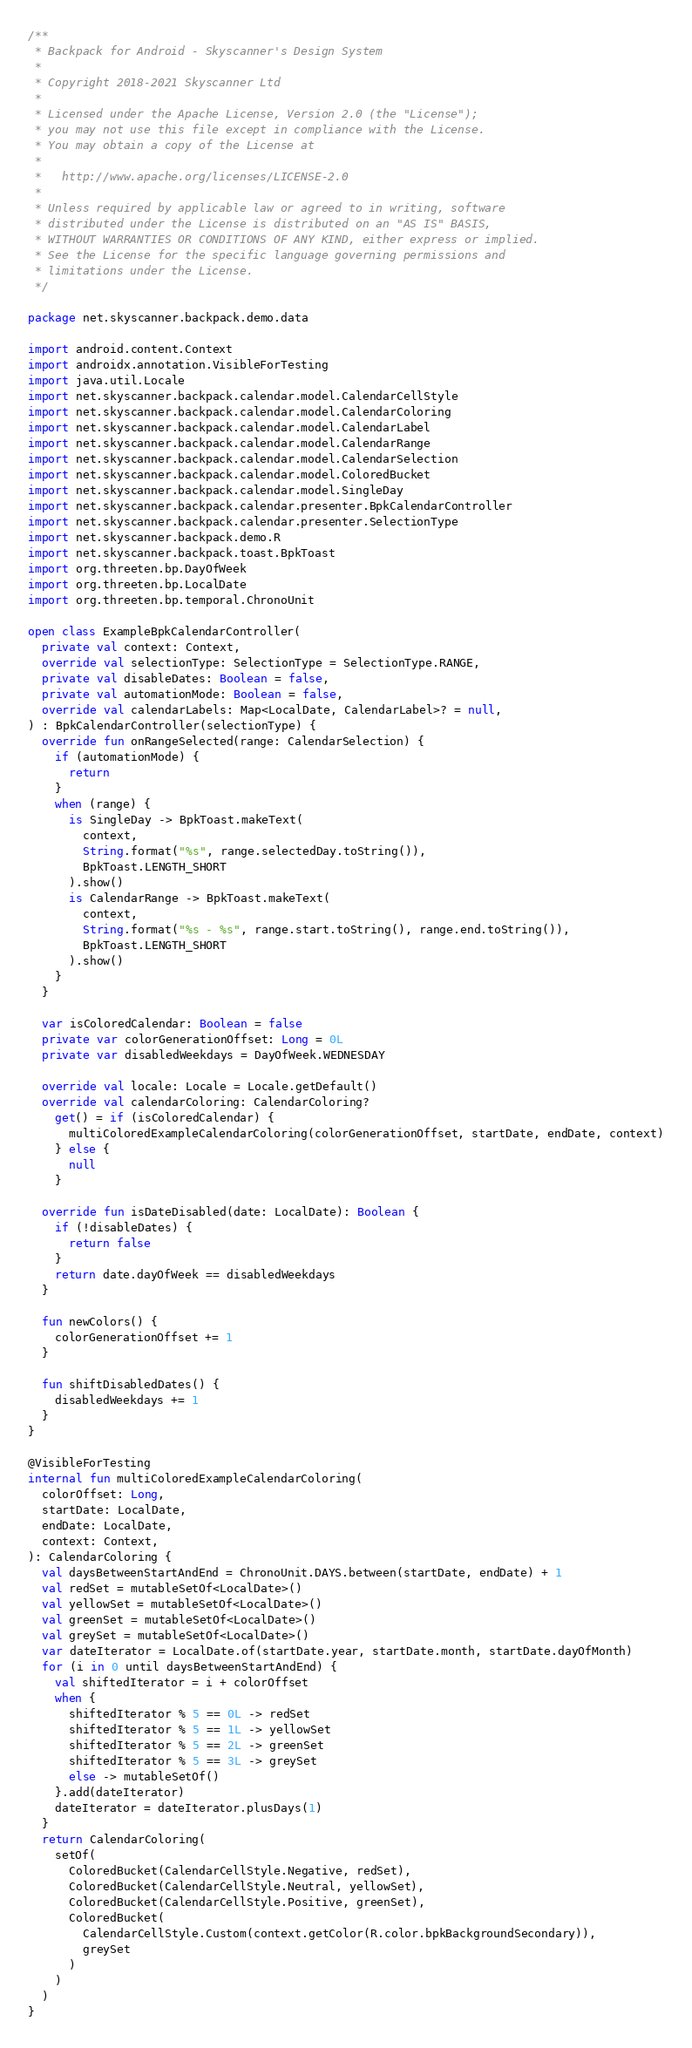<code> <loc_0><loc_0><loc_500><loc_500><_Kotlin_>/**
 * Backpack for Android - Skyscanner's Design System
 *
 * Copyright 2018-2021 Skyscanner Ltd
 *
 * Licensed under the Apache License, Version 2.0 (the "License");
 * you may not use this file except in compliance with the License.
 * You may obtain a copy of the License at
 *
 *   http://www.apache.org/licenses/LICENSE-2.0
 *
 * Unless required by applicable law or agreed to in writing, software
 * distributed under the License is distributed on an "AS IS" BASIS,
 * WITHOUT WARRANTIES OR CONDITIONS OF ANY KIND, either express or implied.
 * See the License for the specific language governing permissions and
 * limitations under the License.
 */

package net.skyscanner.backpack.demo.data

import android.content.Context
import androidx.annotation.VisibleForTesting
import java.util.Locale
import net.skyscanner.backpack.calendar.model.CalendarCellStyle
import net.skyscanner.backpack.calendar.model.CalendarColoring
import net.skyscanner.backpack.calendar.model.CalendarLabel
import net.skyscanner.backpack.calendar.model.CalendarRange
import net.skyscanner.backpack.calendar.model.CalendarSelection
import net.skyscanner.backpack.calendar.model.ColoredBucket
import net.skyscanner.backpack.calendar.model.SingleDay
import net.skyscanner.backpack.calendar.presenter.BpkCalendarController
import net.skyscanner.backpack.calendar.presenter.SelectionType
import net.skyscanner.backpack.demo.R
import net.skyscanner.backpack.toast.BpkToast
import org.threeten.bp.DayOfWeek
import org.threeten.bp.LocalDate
import org.threeten.bp.temporal.ChronoUnit

open class ExampleBpkCalendarController(
  private val context: Context,
  override val selectionType: SelectionType = SelectionType.RANGE,
  private val disableDates: Boolean = false,
  private val automationMode: Boolean = false,
  override val calendarLabels: Map<LocalDate, CalendarLabel>? = null,
) : BpkCalendarController(selectionType) {
  override fun onRangeSelected(range: CalendarSelection) {
    if (automationMode) {
      return
    }
    when (range) {
      is SingleDay -> BpkToast.makeText(
        context,
        String.format("%s", range.selectedDay.toString()),
        BpkToast.LENGTH_SHORT
      ).show()
      is CalendarRange -> BpkToast.makeText(
        context,
        String.format("%s - %s", range.start.toString(), range.end.toString()),
        BpkToast.LENGTH_SHORT
      ).show()
    }
  }

  var isColoredCalendar: Boolean = false
  private var colorGenerationOffset: Long = 0L
  private var disabledWeekdays = DayOfWeek.WEDNESDAY

  override val locale: Locale = Locale.getDefault()
  override val calendarColoring: CalendarColoring?
    get() = if (isColoredCalendar) {
      multiColoredExampleCalendarColoring(colorGenerationOffset, startDate, endDate, context)
    } else {
      null
    }

  override fun isDateDisabled(date: LocalDate): Boolean {
    if (!disableDates) {
      return false
    }
    return date.dayOfWeek == disabledWeekdays
  }

  fun newColors() {
    colorGenerationOffset += 1
  }

  fun shiftDisabledDates() {
    disabledWeekdays += 1
  }
}

@VisibleForTesting
internal fun multiColoredExampleCalendarColoring(
  colorOffset: Long,
  startDate: LocalDate,
  endDate: LocalDate,
  context: Context,
): CalendarColoring {
  val daysBetweenStartAndEnd = ChronoUnit.DAYS.between(startDate, endDate) + 1
  val redSet = mutableSetOf<LocalDate>()
  val yellowSet = mutableSetOf<LocalDate>()
  val greenSet = mutableSetOf<LocalDate>()
  val greySet = mutableSetOf<LocalDate>()
  var dateIterator = LocalDate.of(startDate.year, startDate.month, startDate.dayOfMonth)
  for (i in 0 until daysBetweenStartAndEnd) {
    val shiftedIterator = i + colorOffset
    when {
      shiftedIterator % 5 == 0L -> redSet
      shiftedIterator % 5 == 1L -> yellowSet
      shiftedIterator % 5 == 2L -> greenSet
      shiftedIterator % 5 == 3L -> greySet
      else -> mutableSetOf()
    }.add(dateIterator)
    dateIterator = dateIterator.plusDays(1)
  }
  return CalendarColoring(
    setOf(
      ColoredBucket(CalendarCellStyle.Negative, redSet),
      ColoredBucket(CalendarCellStyle.Neutral, yellowSet),
      ColoredBucket(CalendarCellStyle.Positive, greenSet),
      ColoredBucket(
        CalendarCellStyle.Custom(context.getColor(R.color.bpkBackgroundSecondary)),
        greySet
      )
    )
  )
}
</code> 